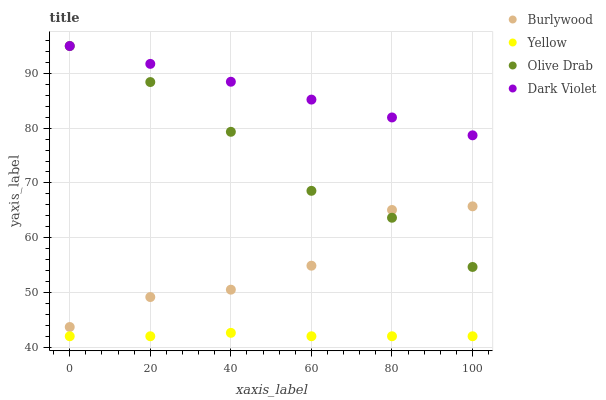Does Yellow have the minimum area under the curve?
Answer yes or no. Yes. Does Dark Violet have the maximum area under the curve?
Answer yes or no. Yes. Does Olive Drab have the minimum area under the curve?
Answer yes or no. No. Does Olive Drab have the maximum area under the curve?
Answer yes or no. No. Is Dark Violet the smoothest?
Answer yes or no. Yes. Is Burlywood the roughest?
Answer yes or no. Yes. Is Olive Drab the smoothest?
Answer yes or no. No. Is Olive Drab the roughest?
Answer yes or no. No. Does Yellow have the lowest value?
Answer yes or no. Yes. Does Olive Drab have the lowest value?
Answer yes or no. No. Does Olive Drab have the highest value?
Answer yes or no. Yes. Does Yellow have the highest value?
Answer yes or no. No. Is Yellow less than Burlywood?
Answer yes or no. Yes. Is Olive Drab greater than Yellow?
Answer yes or no. Yes. Does Burlywood intersect Olive Drab?
Answer yes or no. Yes. Is Burlywood less than Olive Drab?
Answer yes or no. No. Is Burlywood greater than Olive Drab?
Answer yes or no. No. Does Yellow intersect Burlywood?
Answer yes or no. No. 